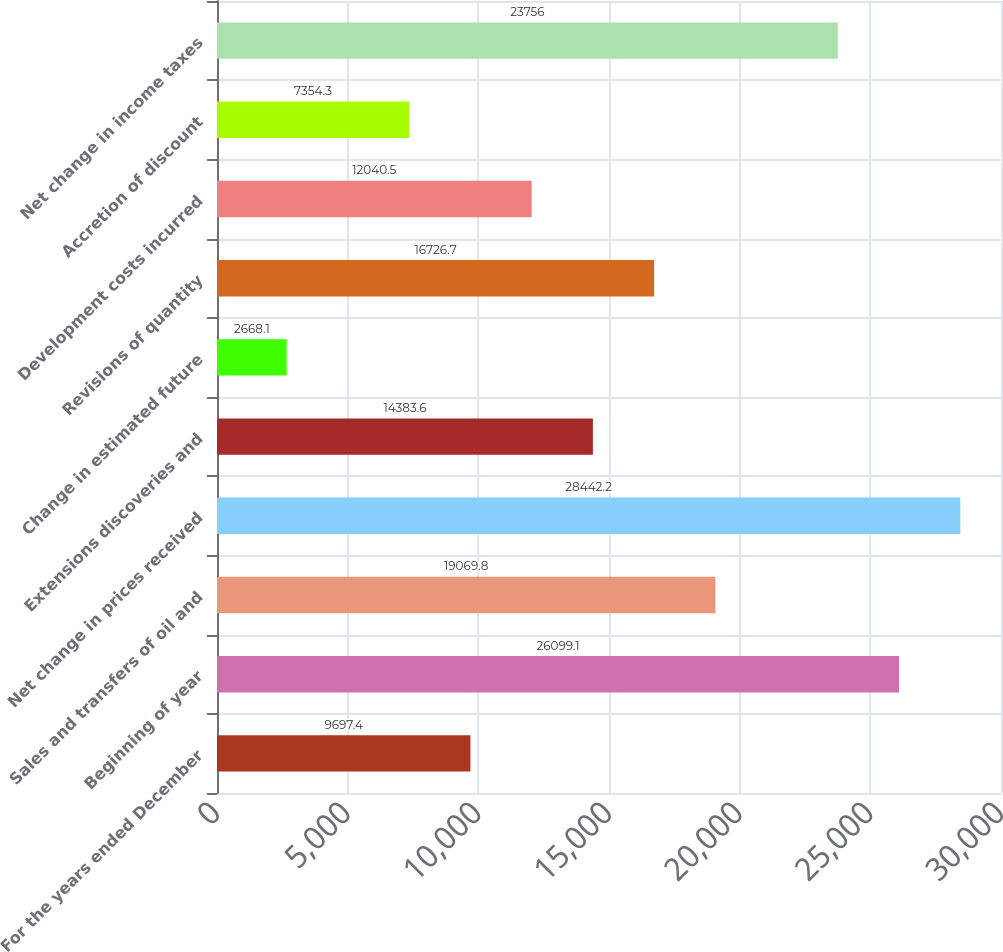Convert chart. <chart><loc_0><loc_0><loc_500><loc_500><bar_chart><fcel>For the years ended December<fcel>Beginning of year<fcel>Sales and transfers of oil and<fcel>Net change in prices received<fcel>Extensions discoveries and<fcel>Change in estimated future<fcel>Revisions of quantity<fcel>Development costs incurred<fcel>Accretion of discount<fcel>Net change in income taxes<nl><fcel>9697.4<fcel>26099.1<fcel>19069.8<fcel>28442.2<fcel>14383.6<fcel>2668.1<fcel>16726.7<fcel>12040.5<fcel>7354.3<fcel>23756<nl></chart> 